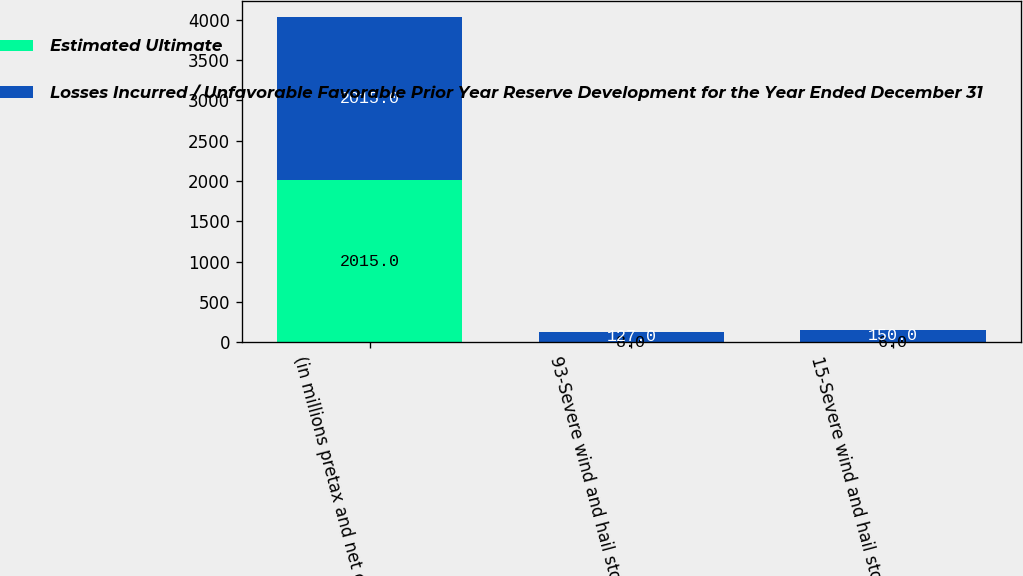<chart> <loc_0><loc_0><loc_500><loc_500><stacked_bar_chart><ecel><fcel>(in millions pretax and net of<fcel>93-Severe wind and hail storms<fcel>15-Severe wind and hail storms<nl><fcel>Estimated Ultimate<fcel>2015<fcel>8<fcel>6<nl><fcel>Losses Incurred / Unfavorable Favorable Prior Year Reserve Development for the Year Ended December 31<fcel>2015<fcel>127<fcel>150<nl></chart> 